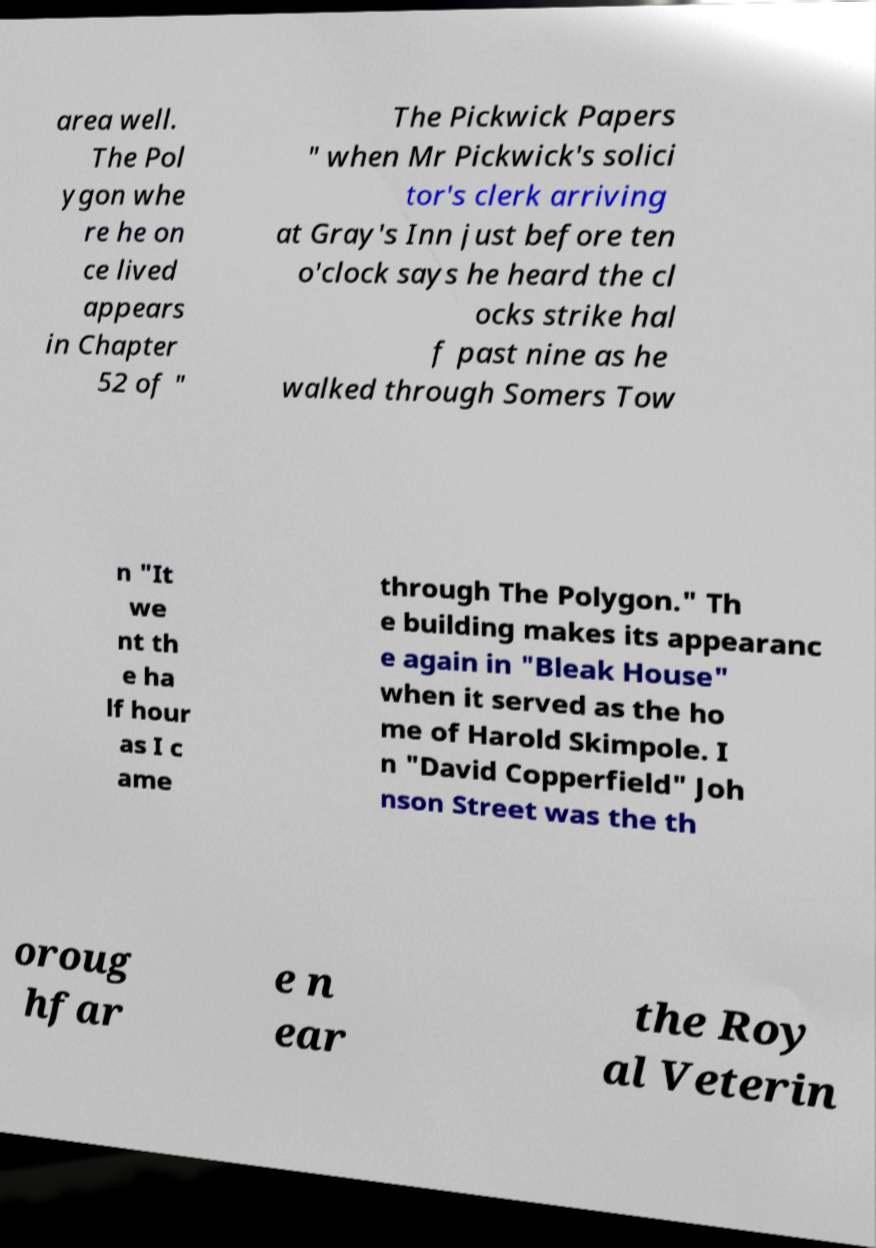I need the written content from this picture converted into text. Can you do that? area well. The Pol ygon whe re he on ce lived appears in Chapter 52 of " The Pickwick Papers " when Mr Pickwick's solici tor's clerk arriving at Gray's Inn just before ten o'clock says he heard the cl ocks strike hal f past nine as he walked through Somers Tow n "It we nt th e ha lf hour as I c ame through The Polygon." Th e building makes its appearanc e again in "Bleak House" when it served as the ho me of Harold Skimpole. I n "David Copperfield" Joh nson Street was the th oroug hfar e n ear the Roy al Veterin 